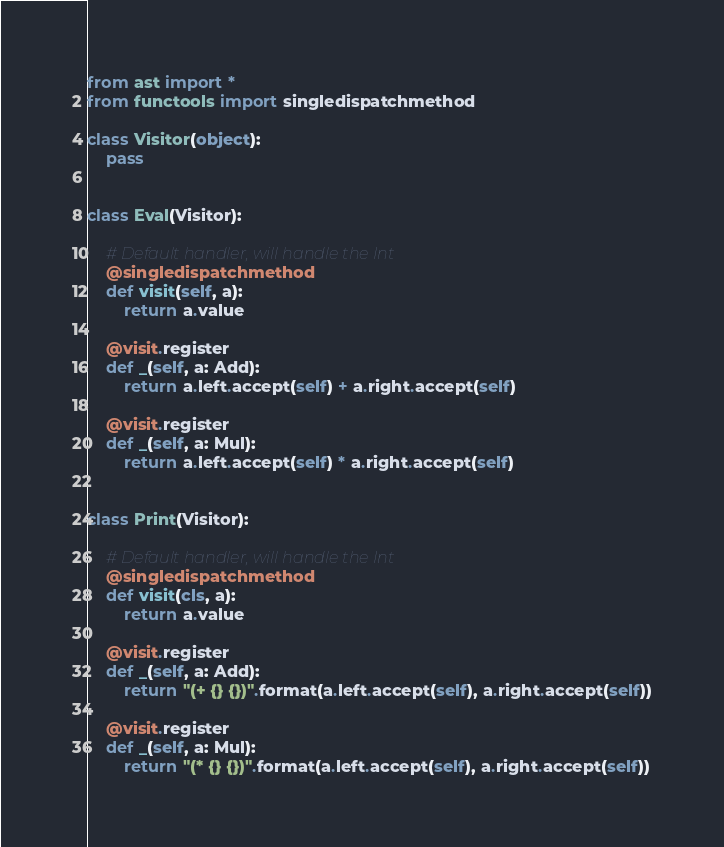<code> <loc_0><loc_0><loc_500><loc_500><_Python_>from ast import *
from functools import singledispatchmethod

class Visitor(object):
    pass


class Eval(Visitor):

    # Default handler, will handle the Int
    @singledispatchmethod
    def visit(self, a):
        return a.value

    @visit.register
    def _(self, a: Add):
        return a.left.accept(self) + a.right.accept(self)

    @visit.register
    def _(self, a: Mul):
        return a.left.accept(self) * a.right.accept(self)


class Print(Visitor):

    # Default handler, will handle the Int
    @singledispatchmethod
    def visit(cls, a):
        return a.value

    @visit.register
    def _(self, a: Add):
        return "(+ {} {})".format(a.left.accept(self), a.right.accept(self))

    @visit.register
    def _(self, a: Mul):
        return "(* {} {})".format(a.left.accept(self), a.right.accept(self))



</code> 